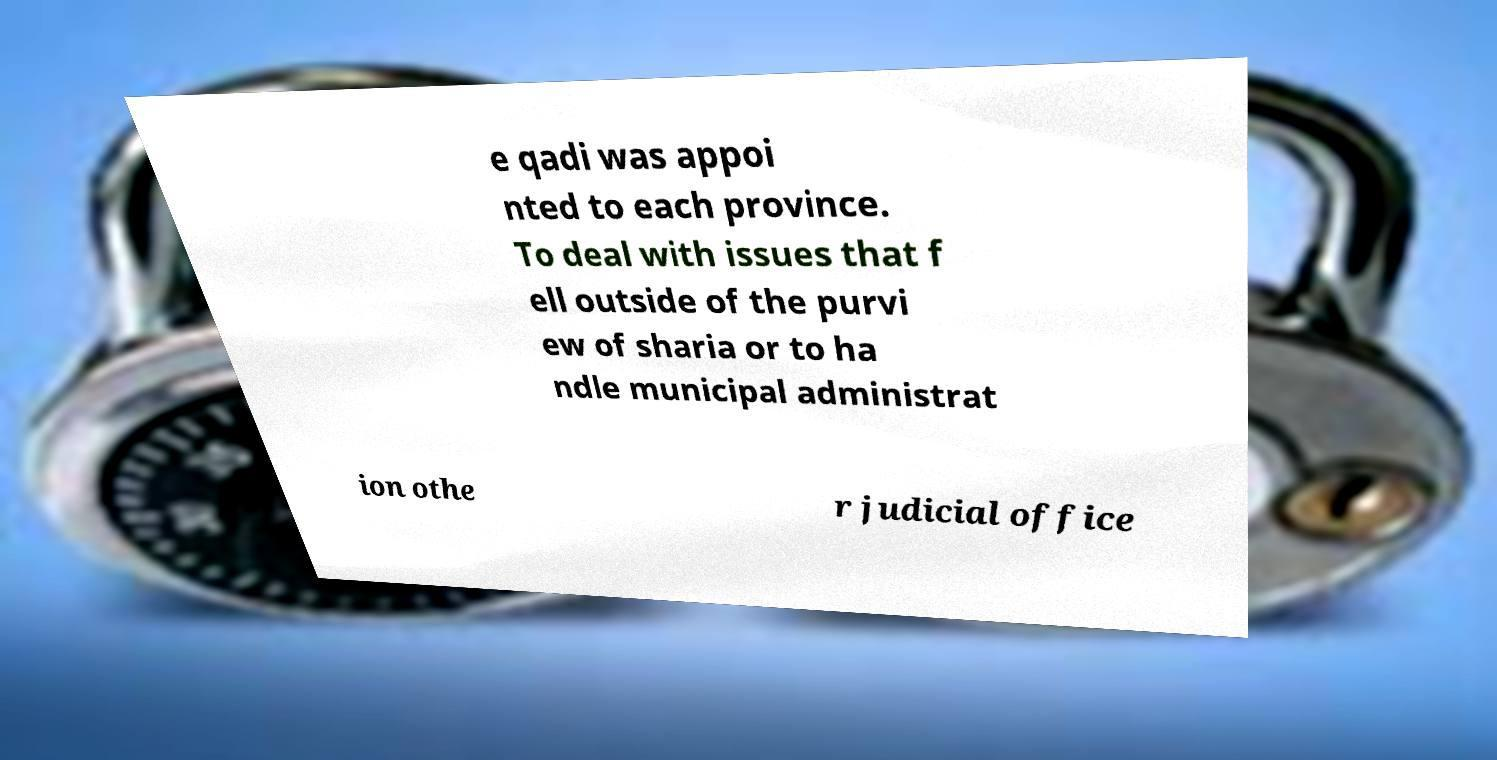For documentation purposes, I need the text within this image transcribed. Could you provide that? e qadi was appoi nted to each province. To deal with issues that f ell outside of the purvi ew of sharia or to ha ndle municipal administrat ion othe r judicial office 